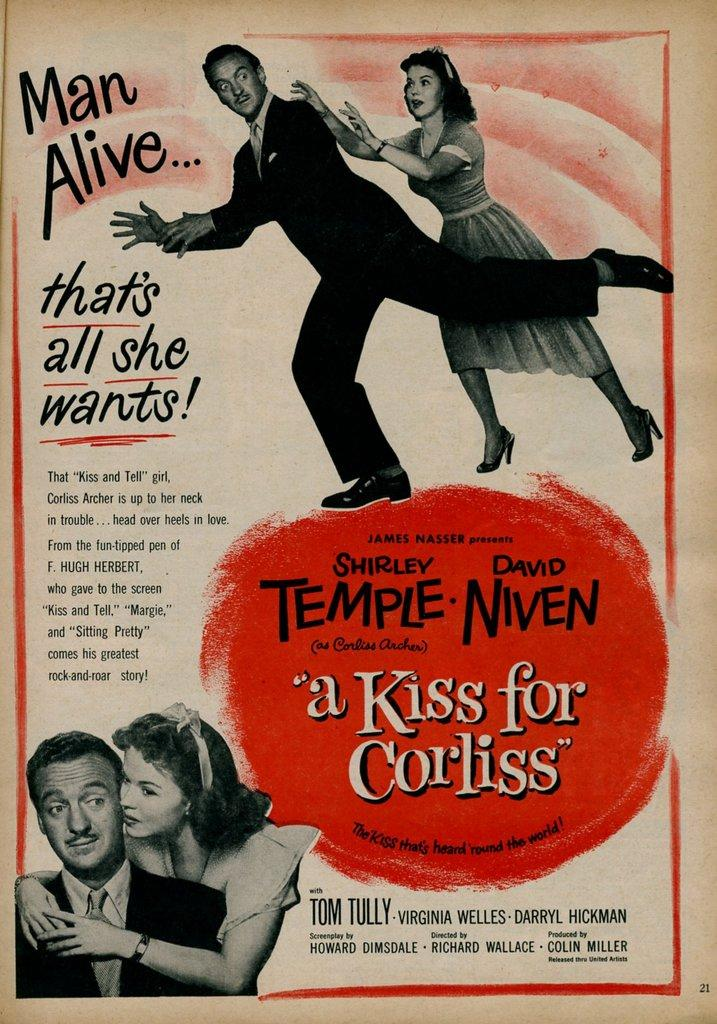Provide a one-sentence caption for the provided image. Howard Dimsdale wrote the screenplay for a Kiss for Corliss. 